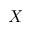Convert formula to latex. <formula><loc_0><loc_0><loc_500><loc_500>X</formula> 